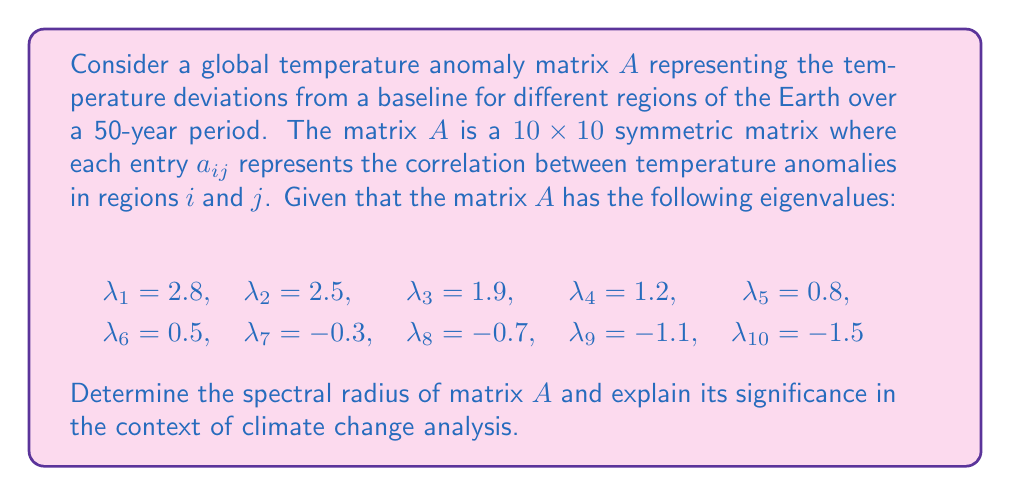Help me with this question. To solve this problem, we need to understand the concept of spectral radius and its relevance to climate science:

1. The spectral radius of a matrix is defined as the maximum absolute value of its eigenvalues. Mathematically, for a matrix $A$ with eigenvalues $\lambda_i$, the spectral radius $\rho(A)$ is given by:

   $$\rho(A) = \max_{i} |\lambda_i|$$

2. In the context of climate change analysis, the spectral radius of a temperature anomaly matrix can provide insights into the overall magnitude of temperature deviations and the potential for amplification of climate signals.

3. To find the spectral radius, we need to identify the eigenvalue with the largest absolute value:

   $|\lambda_1| = 2.8$
   $|\lambda_2| = 2.5$
   $|\lambda_3| = 1.9$
   $|\lambda_4| = 1.2$
   $|\lambda_5| = 0.8$
   $|\lambda_6| = 0.5$
   $|\lambda_7| = 0.3$
   $|\lambda_8| = 0.7$
   $|\lambda_9| = 1.1$
   $|\lambda_{10}| = 1.5$

4. The largest absolute value among these eigenvalues is 2.8, corresponding to $\lambda_1$.

5. Therefore, the spectral radius of matrix $A$ is 2.8.

Significance in climate change analysis:
a) The spectral radius provides an upper bound for the long-term behavior of temperature anomalies when considering the linear dynamics represented by the matrix.
b) A larger spectral radius suggests a higher potential for amplification of temperature deviations over time, which could indicate more severe climate change impacts.
c) The positive value of the spectral radius (2.8) indicates that the dominant mode of variability in this temperature anomaly matrix is associated with warming rather than cooling.
d) The magnitude of the spectral radius can be used to compare the intensity of temperature anomalies across different regions or time periods, helping prioritize areas for climate change mitigation efforts.
Answer: The spectral radius of the global temperature anomaly matrix $A$ is 2.8. 